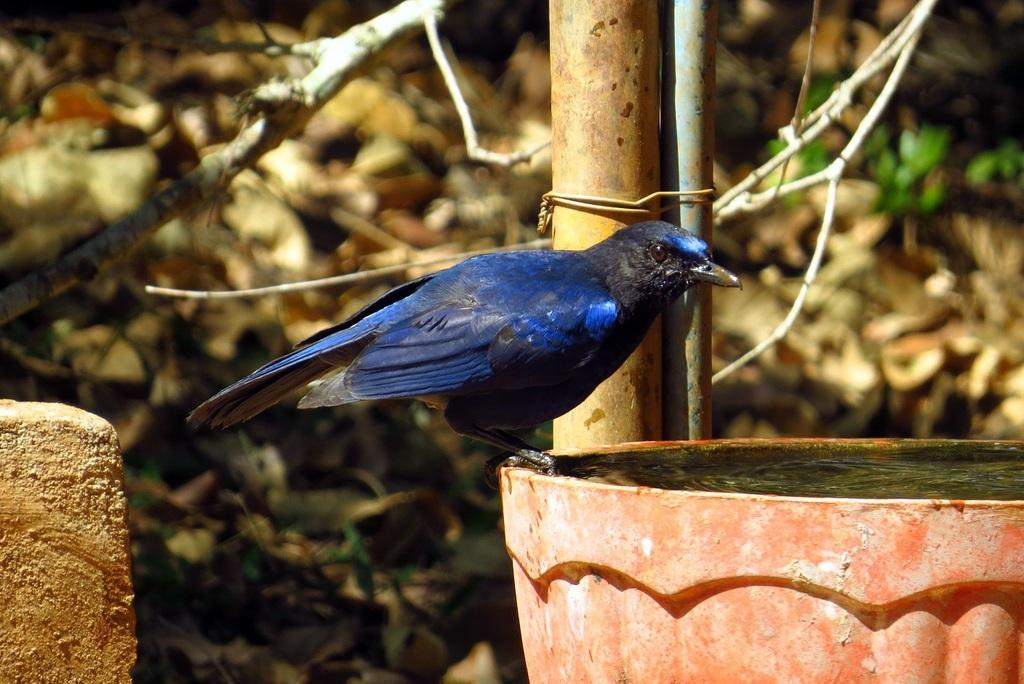What type of animal can be seen in the image? There is a bird in the image. What is located in the middle of the image? There is a pole in the middle of the image. What can be seen in the background of the image? Leaves and stems are present in the background of the image. What is the price of the laborer in the image? There is no laborer present in the image, so it is not possible to determine a price. 